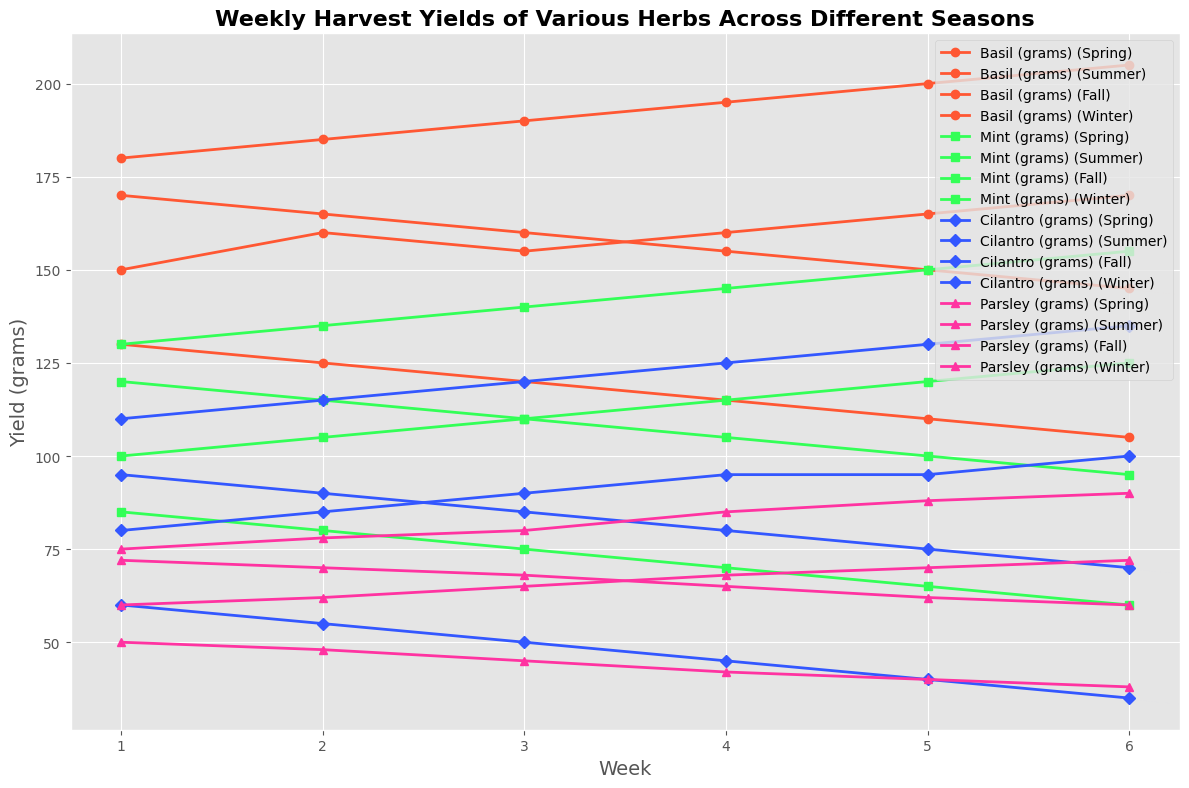What season has the highest overall yield for Basil? Looking at the plot, identify the peak weeks for each season and note the highest value for Basil. Summer has the highest yields, with the maximum value reaching 205 grams in week 6.
Answer: Summer How do Mint yields in Spring compare to those in Fall in week 3? Find the Mint yield for Spring week 3 (110 grams) and Fall week 3 (110 grams). Both values are the same.
Answer: They are equal What's the total yield of Parsley over the Summer season? Sum up the weekly yields of Parsley in the Summer season: 75 + 78 + 80 + 85 + 88 + 90 = 496 grams.
Answer: 496 grams Which herb shows the largest decline in yield from Summer to Winter? Observe the difference between the highest value in Summer and the lowest value in Winter for each herb: Basil (205 - 105 = 100), Mint (155 - 60 = 95), Cilantro (135 - 35 = 100), Parsley (90 - 38 = 52). Basil and Cilantro show the largest decline of 100 grams.
Answer: Basil and Cilantro In which week does Cilantro reach its peak yield, and what is it? Identify the peak yield of Cilantro from the plot, which is in Summer week 6 with 135 grams.
Answer: Summer week 6, 135 grams Which season has the most consistent yield for Mint, measured by the smallest difference between the highest and lowest weekly yields? Calculate the difference between the highest and lowest yields for Mint in each season: Spring (125 - 100 = 25), Summer (155 - 130 = 25), Fall (120 - 95 = 25), Winter (85 - 60 = 25). All seasons show the same difference of 25 grams.
Answer: All seasons are equally consistent What is the average weekly yield of Cilantro in Winter? Sum up the weekly yields of Cilantro in Winter: 60 + 55 + 50 + 45 + 40 + 35 = 285 grams. The average is 285/6 = 47.5 grams.
Answer: 47.5 grams Which week in Fall shows the lowest yield for Basil, and how much is it? Locate the week with the lowest Basil yield in Fall, which is week 6 with 145 grams.
Answer: Fall week 6, 145 grams Is there any herb that shows a steady increase in yield throughout Spring? Check the plot for each herb in Spring and see if yields increase each week. Parsley shows a steady rise from 60 grams (week 1) to 72 grams (week 6).
Answer: Parsley 